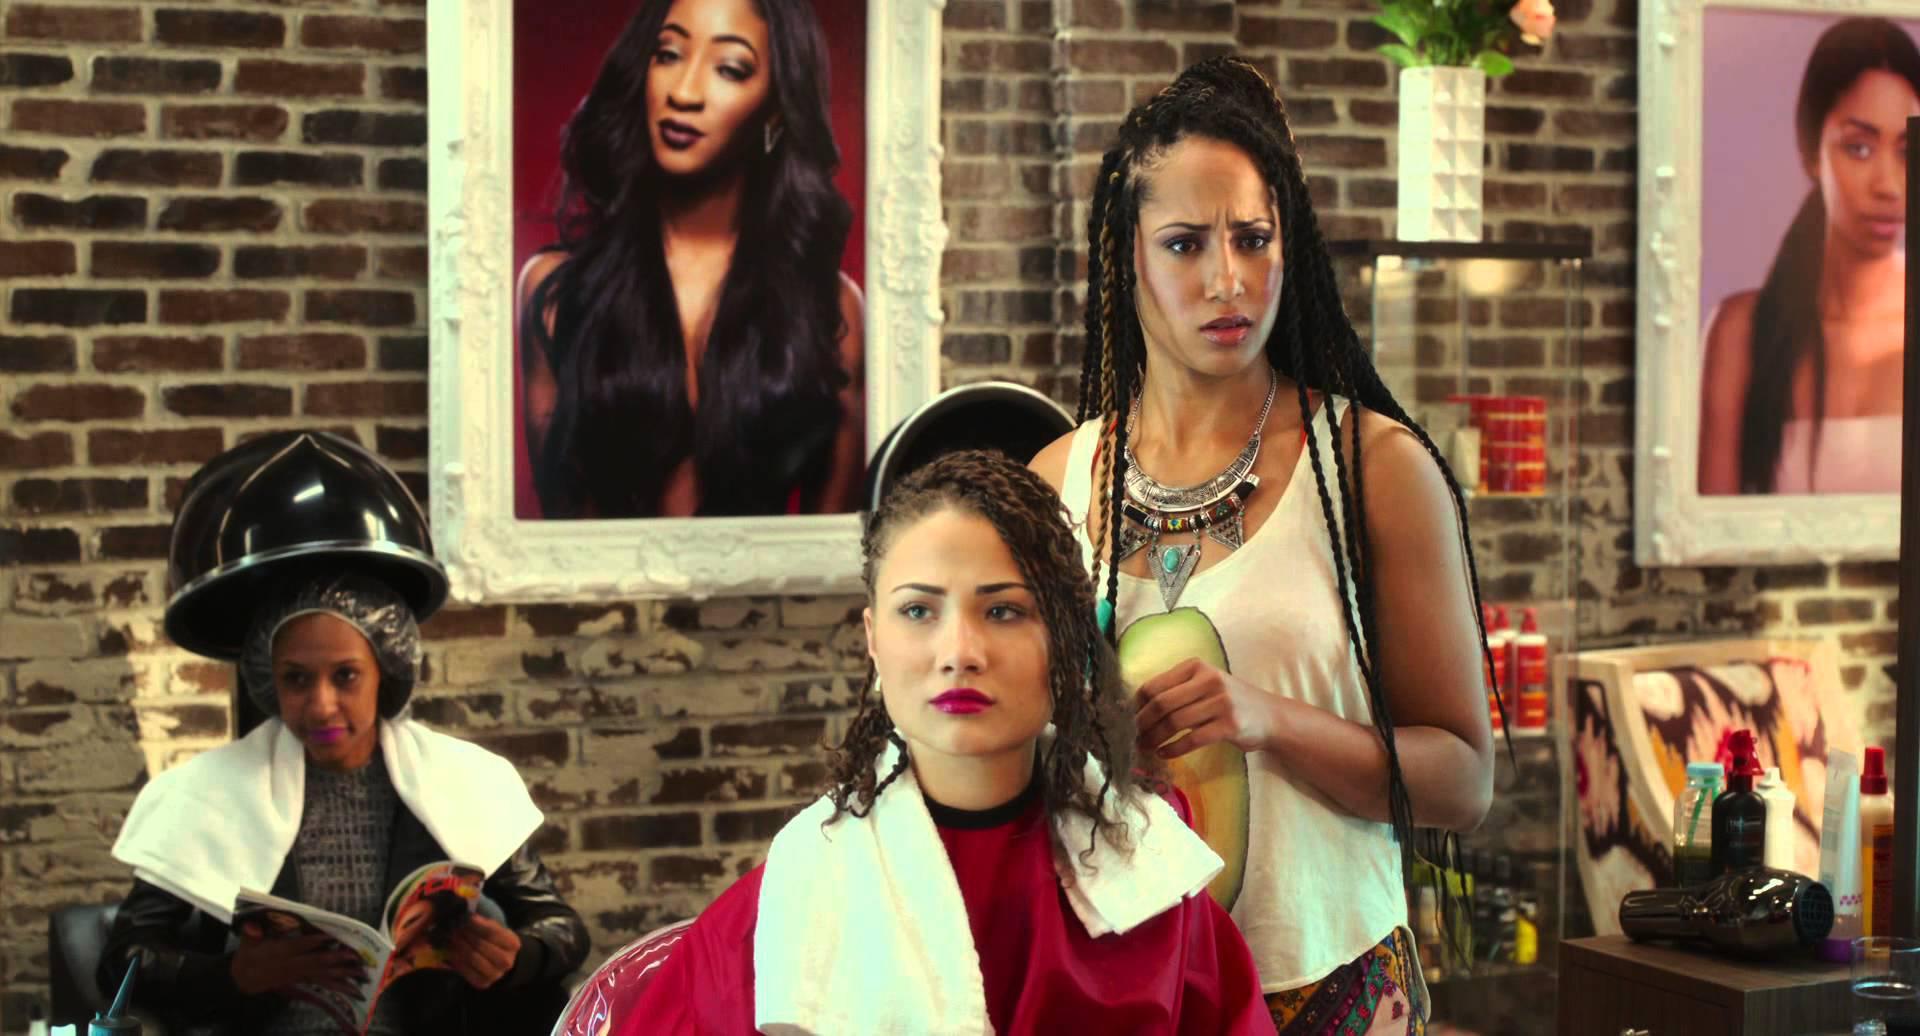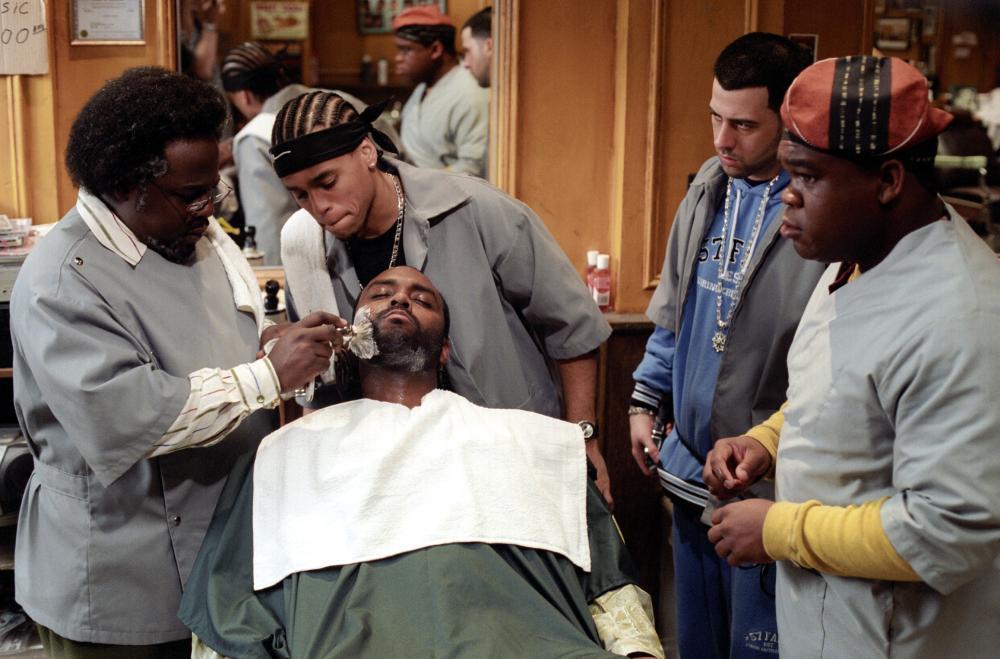The first image is the image on the left, the second image is the image on the right. Considering the images on both sides, is "A barber is working on a former US president in one of the images" valid? Answer yes or no. No. The first image is the image on the left, the second image is the image on the right. For the images shown, is this caption "A barbershop scene includes at least two real non-smiling women." true? Answer yes or no. Yes. 